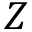Convert formula to latex. <formula><loc_0><loc_0><loc_500><loc_500>Z</formula> 